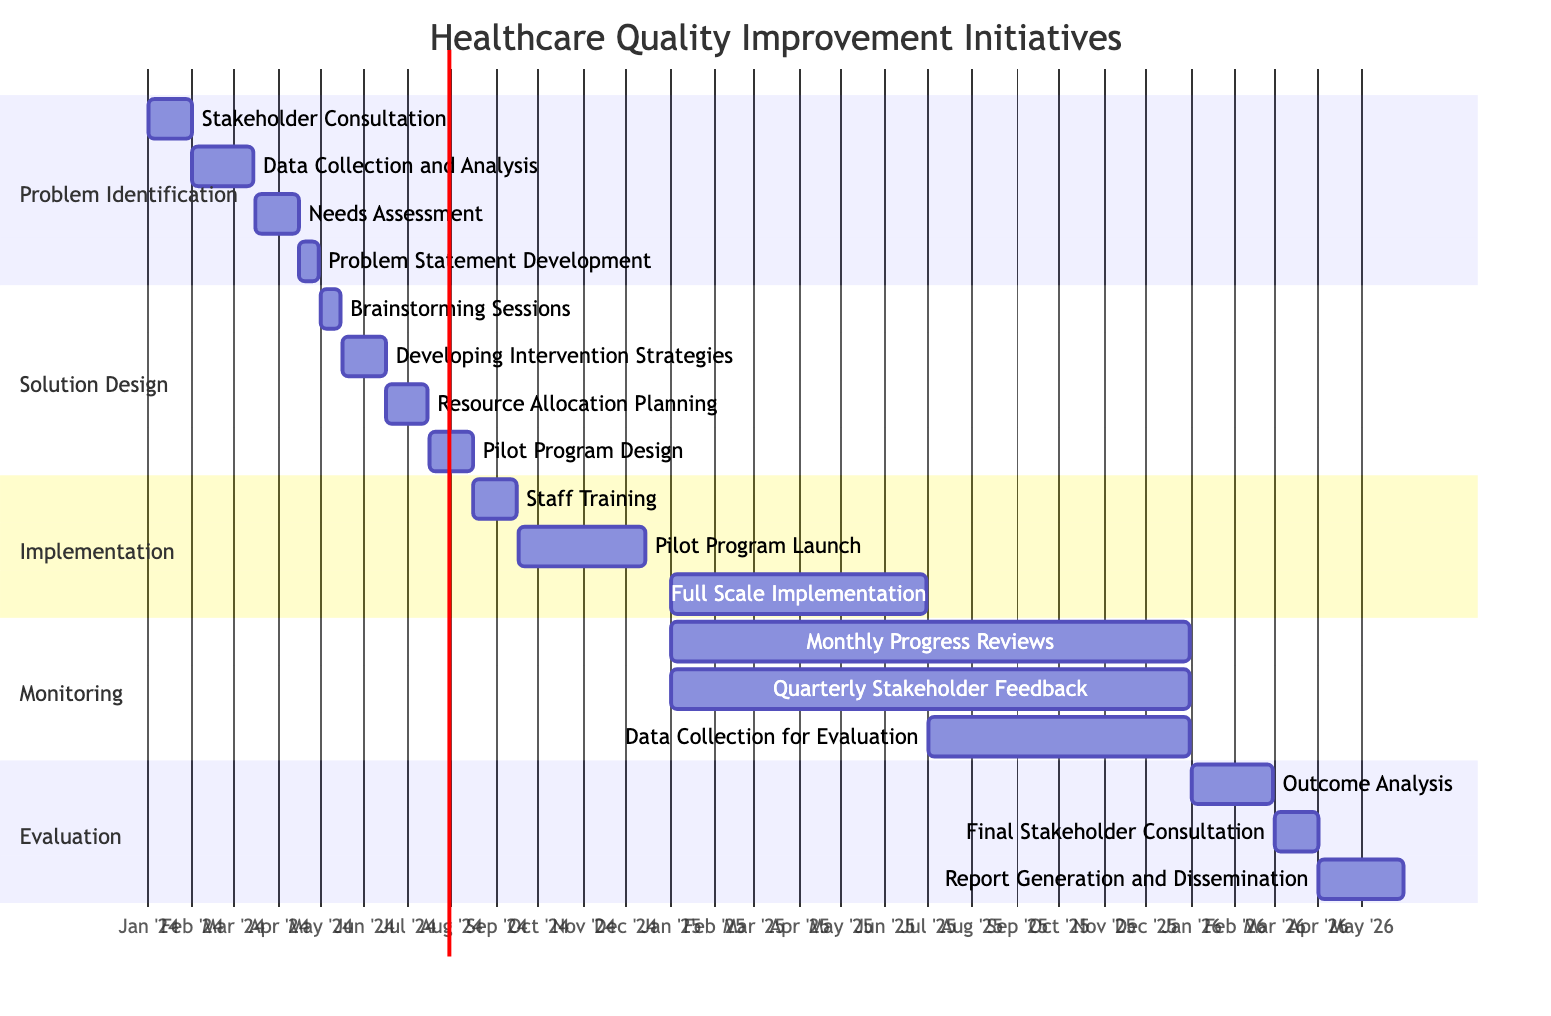What is the duration of the "Data Collection and Analysis" task? The task "Data Collection and Analysis" starts on February 1, 2024, and ends on March 15, 2024. To calculate the duration, we count the number of days: from February 1 to March 15 is 43 days.
Answer: 43 days Which task follows "Needs Assessment" in the Gantt chart? The task "Needs Assessment" ends on April 15, 2024. The next task starting immediately after this is "Problem Statement Development," which begins on April 16, 2024.
Answer: Problem Statement Development How many total tasks are included in the "Implementation" phase? In the "Implementation" phase, there are three tasks listed: "Staff Training," "Pilot Program Launch," and "Full Scale Implementation." Thus, the total number of tasks is three.
Answer: 3 What is the start date of the "Final Stakeholder Consultation"? The "Final Stakeholder Consultation" task starts on March 1, 2026. This can be directly found in the "Evaluation" section of the Gantt chart.
Answer: March 1, 2026 Which phase has the task with the latest end date? The "Monitoring" phase includes a task titled "Monthly Progress Reviews" that ends on December 31, 2025, which is the latest end date among all highlighted tasks across all phases.
Answer: Monitoring What is the order of tasks in the "Solution Design" phase? The tasks in the "Solution Design" phase are ordered as follows: "Brainstorming Sessions," followed by "Developing Intervention Strategies," then "Resource Allocation Planning," and finally "Pilot Program Design." This order is based on their start dates and appearances in the section.
Answer: Brainstorming Sessions, Developing Intervention Strategies, Resource Allocation Planning, Pilot Program Design During which months does "Pilot Program Launch" occur? The "Pilot Program Launch" task starts on September 16, 2024, and ends on December 15, 2024. This time frame includes parts of September, October, November, and December.
Answer: September, October, November, December How long does the "Outcome Analysis" period last? The "Outcome Analysis" task begins on January 1, 2026, and ends on February 28, 2026. To find the duration, we consider January (31 days) and February (28 days), totaling 59 days.
Answer: 59 days 